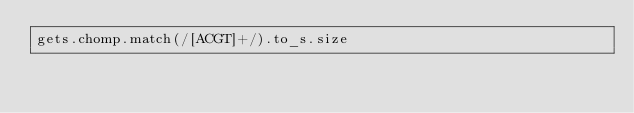<code> <loc_0><loc_0><loc_500><loc_500><_Ruby_>gets.chomp.match(/[ACGT]+/).to_s.size</code> 